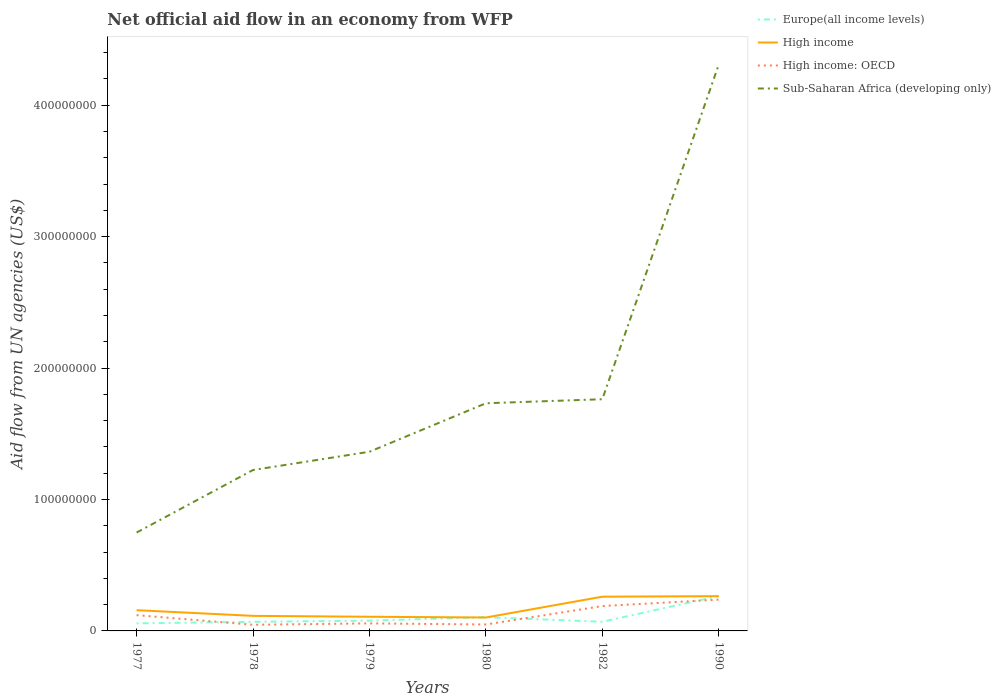Does the line corresponding to Europe(all income levels) intersect with the line corresponding to High income?
Provide a short and direct response. Yes. Across all years, what is the maximum net official aid flow in Europe(all income levels)?
Provide a short and direct response. 5.76e+06. What is the total net official aid flow in High income in the graph?
Offer a very short reply. -1.46e+07. What is the difference between the highest and the second highest net official aid flow in Sub-Saharan Africa (developing only)?
Provide a succinct answer. 3.56e+08. What is the difference between two consecutive major ticks on the Y-axis?
Give a very brief answer. 1.00e+08. Are the values on the major ticks of Y-axis written in scientific E-notation?
Give a very brief answer. No. Does the graph contain grids?
Your response must be concise. No. How many legend labels are there?
Your response must be concise. 4. How are the legend labels stacked?
Make the answer very short. Vertical. What is the title of the graph?
Provide a short and direct response. Net official aid flow in an economy from WFP. What is the label or title of the Y-axis?
Your response must be concise. Aid flow from UN agencies (US$). What is the Aid flow from UN agencies (US$) in Europe(all income levels) in 1977?
Provide a succinct answer. 5.76e+06. What is the Aid flow from UN agencies (US$) of High income in 1977?
Provide a short and direct response. 1.58e+07. What is the Aid flow from UN agencies (US$) of High income: OECD in 1977?
Offer a terse response. 1.20e+07. What is the Aid flow from UN agencies (US$) of Sub-Saharan Africa (developing only) in 1977?
Offer a terse response. 7.48e+07. What is the Aid flow from UN agencies (US$) in Europe(all income levels) in 1978?
Offer a terse response. 6.93e+06. What is the Aid flow from UN agencies (US$) of High income in 1978?
Your answer should be very brief. 1.15e+07. What is the Aid flow from UN agencies (US$) in High income: OECD in 1978?
Your response must be concise. 4.68e+06. What is the Aid flow from UN agencies (US$) in Sub-Saharan Africa (developing only) in 1978?
Keep it short and to the point. 1.22e+08. What is the Aid flow from UN agencies (US$) in Europe(all income levels) in 1979?
Make the answer very short. 7.82e+06. What is the Aid flow from UN agencies (US$) in High income in 1979?
Provide a short and direct response. 1.08e+07. What is the Aid flow from UN agencies (US$) of High income: OECD in 1979?
Give a very brief answer. 5.74e+06. What is the Aid flow from UN agencies (US$) of Sub-Saharan Africa (developing only) in 1979?
Offer a very short reply. 1.36e+08. What is the Aid flow from UN agencies (US$) in Europe(all income levels) in 1980?
Offer a terse response. 1.05e+07. What is the Aid flow from UN agencies (US$) in High income in 1980?
Provide a short and direct response. 1.02e+07. What is the Aid flow from UN agencies (US$) in High income: OECD in 1980?
Offer a very short reply. 4.90e+06. What is the Aid flow from UN agencies (US$) in Sub-Saharan Africa (developing only) in 1980?
Offer a very short reply. 1.73e+08. What is the Aid flow from UN agencies (US$) in Europe(all income levels) in 1982?
Offer a very short reply. 6.96e+06. What is the Aid flow from UN agencies (US$) in High income in 1982?
Provide a short and direct response. 2.60e+07. What is the Aid flow from UN agencies (US$) of High income: OECD in 1982?
Your answer should be compact. 1.89e+07. What is the Aid flow from UN agencies (US$) in Sub-Saharan Africa (developing only) in 1982?
Your answer should be very brief. 1.76e+08. What is the Aid flow from UN agencies (US$) in Europe(all income levels) in 1990?
Offer a terse response. 2.65e+07. What is the Aid flow from UN agencies (US$) of High income in 1990?
Provide a short and direct response. 2.64e+07. What is the Aid flow from UN agencies (US$) in High income: OECD in 1990?
Ensure brevity in your answer.  2.38e+07. What is the Aid flow from UN agencies (US$) in Sub-Saharan Africa (developing only) in 1990?
Offer a very short reply. 4.31e+08. Across all years, what is the maximum Aid flow from UN agencies (US$) in Europe(all income levels)?
Provide a short and direct response. 2.65e+07. Across all years, what is the maximum Aid flow from UN agencies (US$) in High income?
Provide a succinct answer. 2.64e+07. Across all years, what is the maximum Aid flow from UN agencies (US$) in High income: OECD?
Your answer should be compact. 2.38e+07. Across all years, what is the maximum Aid flow from UN agencies (US$) in Sub-Saharan Africa (developing only)?
Ensure brevity in your answer.  4.31e+08. Across all years, what is the minimum Aid flow from UN agencies (US$) in Europe(all income levels)?
Keep it short and to the point. 5.76e+06. Across all years, what is the minimum Aid flow from UN agencies (US$) in High income?
Your response must be concise. 1.02e+07. Across all years, what is the minimum Aid flow from UN agencies (US$) in High income: OECD?
Your response must be concise. 4.68e+06. Across all years, what is the minimum Aid flow from UN agencies (US$) in Sub-Saharan Africa (developing only)?
Offer a very short reply. 7.48e+07. What is the total Aid flow from UN agencies (US$) of Europe(all income levels) in the graph?
Offer a very short reply. 6.45e+07. What is the total Aid flow from UN agencies (US$) of High income in the graph?
Offer a very short reply. 1.01e+08. What is the total Aid flow from UN agencies (US$) in High income: OECD in the graph?
Your answer should be compact. 7.01e+07. What is the total Aid flow from UN agencies (US$) in Sub-Saharan Africa (developing only) in the graph?
Your response must be concise. 1.11e+09. What is the difference between the Aid flow from UN agencies (US$) in Europe(all income levels) in 1977 and that in 1978?
Ensure brevity in your answer.  -1.17e+06. What is the difference between the Aid flow from UN agencies (US$) of High income in 1977 and that in 1978?
Give a very brief answer. 4.32e+06. What is the difference between the Aid flow from UN agencies (US$) of High income: OECD in 1977 and that in 1978?
Make the answer very short. 7.34e+06. What is the difference between the Aid flow from UN agencies (US$) of Sub-Saharan Africa (developing only) in 1977 and that in 1978?
Provide a succinct answer. -4.76e+07. What is the difference between the Aid flow from UN agencies (US$) in Europe(all income levels) in 1977 and that in 1979?
Ensure brevity in your answer.  -2.06e+06. What is the difference between the Aid flow from UN agencies (US$) in High income in 1977 and that in 1979?
Ensure brevity in your answer.  5.01e+06. What is the difference between the Aid flow from UN agencies (US$) of High income: OECD in 1977 and that in 1979?
Give a very brief answer. 6.28e+06. What is the difference between the Aid flow from UN agencies (US$) of Sub-Saharan Africa (developing only) in 1977 and that in 1979?
Ensure brevity in your answer.  -6.15e+07. What is the difference between the Aid flow from UN agencies (US$) in Europe(all income levels) in 1977 and that in 1980?
Make the answer very short. -4.70e+06. What is the difference between the Aid flow from UN agencies (US$) of High income in 1977 and that in 1980?
Keep it short and to the point. 5.57e+06. What is the difference between the Aid flow from UN agencies (US$) of High income: OECD in 1977 and that in 1980?
Your answer should be very brief. 7.12e+06. What is the difference between the Aid flow from UN agencies (US$) in Sub-Saharan Africa (developing only) in 1977 and that in 1980?
Your answer should be very brief. -9.84e+07. What is the difference between the Aid flow from UN agencies (US$) of Europe(all income levels) in 1977 and that in 1982?
Your answer should be very brief. -1.20e+06. What is the difference between the Aid flow from UN agencies (US$) of High income in 1977 and that in 1982?
Provide a succinct answer. -1.03e+07. What is the difference between the Aid flow from UN agencies (US$) in High income: OECD in 1977 and that in 1982?
Give a very brief answer. -6.90e+06. What is the difference between the Aid flow from UN agencies (US$) of Sub-Saharan Africa (developing only) in 1977 and that in 1982?
Give a very brief answer. -1.01e+08. What is the difference between the Aid flow from UN agencies (US$) of Europe(all income levels) in 1977 and that in 1990?
Ensure brevity in your answer.  -2.08e+07. What is the difference between the Aid flow from UN agencies (US$) of High income in 1977 and that in 1990?
Your response must be concise. -1.07e+07. What is the difference between the Aid flow from UN agencies (US$) of High income: OECD in 1977 and that in 1990?
Provide a succinct answer. -1.18e+07. What is the difference between the Aid flow from UN agencies (US$) in Sub-Saharan Africa (developing only) in 1977 and that in 1990?
Provide a succinct answer. -3.56e+08. What is the difference between the Aid flow from UN agencies (US$) of Europe(all income levels) in 1978 and that in 1979?
Your response must be concise. -8.90e+05. What is the difference between the Aid flow from UN agencies (US$) in High income in 1978 and that in 1979?
Offer a terse response. 6.90e+05. What is the difference between the Aid flow from UN agencies (US$) of High income: OECD in 1978 and that in 1979?
Offer a terse response. -1.06e+06. What is the difference between the Aid flow from UN agencies (US$) of Sub-Saharan Africa (developing only) in 1978 and that in 1979?
Make the answer very short. -1.39e+07. What is the difference between the Aid flow from UN agencies (US$) in Europe(all income levels) in 1978 and that in 1980?
Ensure brevity in your answer.  -3.53e+06. What is the difference between the Aid flow from UN agencies (US$) in High income in 1978 and that in 1980?
Provide a succinct answer. 1.25e+06. What is the difference between the Aid flow from UN agencies (US$) of Sub-Saharan Africa (developing only) in 1978 and that in 1980?
Offer a terse response. -5.08e+07. What is the difference between the Aid flow from UN agencies (US$) in High income in 1978 and that in 1982?
Offer a terse response. -1.46e+07. What is the difference between the Aid flow from UN agencies (US$) of High income: OECD in 1978 and that in 1982?
Offer a terse response. -1.42e+07. What is the difference between the Aid flow from UN agencies (US$) in Sub-Saharan Africa (developing only) in 1978 and that in 1982?
Ensure brevity in your answer.  -5.38e+07. What is the difference between the Aid flow from UN agencies (US$) of Europe(all income levels) in 1978 and that in 1990?
Give a very brief answer. -1.96e+07. What is the difference between the Aid flow from UN agencies (US$) of High income in 1978 and that in 1990?
Your answer should be very brief. -1.50e+07. What is the difference between the Aid flow from UN agencies (US$) in High income: OECD in 1978 and that in 1990?
Ensure brevity in your answer.  -1.91e+07. What is the difference between the Aid flow from UN agencies (US$) in Sub-Saharan Africa (developing only) in 1978 and that in 1990?
Your response must be concise. -3.08e+08. What is the difference between the Aid flow from UN agencies (US$) in Europe(all income levels) in 1979 and that in 1980?
Offer a very short reply. -2.64e+06. What is the difference between the Aid flow from UN agencies (US$) in High income in 1979 and that in 1980?
Make the answer very short. 5.60e+05. What is the difference between the Aid flow from UN agencies (US$) of High income: OECD in 1979 and that in 1980?
Your answer should be very brief. 8.40e+05. What is the difference between the Aid flow from UN agencies (US$) of Sub-Saharan Africa (developing only) in 1979 and that in 1980?
Make the answer very short. -3.69e+07. What is the difference between the Aid flow from UN agencies (US$) in Europe(all income levels) in 1979 and that in 1982?
Your answer should be very brief. 8.60e+05. What is the difference between the Aid flow from UN agencies (US$) in High income in 1979 and that in 1982?
Your answer should be compact. -1.53e+07. What is the difference between the Aid flow from UN agencies (US$) in High income: OECD in 1979 and that in 1982?
Ensure brevity in your answer.  -1.32e+07. What is the difference between the Aid flow from UN agencies (US$) of Sub-Saharan Africa (developing only) in 1979 and that in 1982?
Your answer should be compact. -4.00e+07. What is the difference between the Aid flow from UN agencies (US$) of Europe(all income levels) in 1979 and that in 1990?
Your response must be concise. -1.87e+07. What is the difference between the Aid flow from UN agencies (US$) in High income in 1979 and that in 1990?
Keep it short and to the point. -1.57e+07. What is the difference between the Aid flow from UN agencies (US$) in High income: OECD in 1979 and that in 1990?
Provide a succinct answer. -1.81e+07. What is the difference between the Aid flow from UN agencies (US$) of Sub-Saharan Africa (developing only) in 1979 and that in 1990?
Offer a terse response. -2.95e+08. What is the difference between the Aid flow from UN agencies (US$) of Europe(all income levels) in 1980 and that in 1982?
Provide a succinct answer. 3.50e+06. What is the difference between the Aid flow from UN agencies (US$) in High income in 1980 and that in 1982?
Your response must be concise. -1.58e+07. What is the difference between the Aid flow from UN agencies (US$) in High income: OECD in 1980 and that in 1982?
Ensure brevity in your answer.  -1.40e+07. What is the difference between the Aid flow from UN agencies (US$) of Sub-Saharan Africa (developing only) in 1980 and that in 1982?
Your answer should be compact. -3.08e+06. What is the difference between the Aid flow from UN agencies (US$) of Europe(all income levels) in 1980 and that in 1990?
Give a very brief answer. -1.61e+07. What is the difference between the Aid flow from UN agencies (US$) in High income in 1980 and that in 1990?
Make the answer very short. -1.62e+07. What is the difference between the Aid flow from UN agencies (US$) of High income: OECD in 1980 and that in 1990?
Your answer should be very brief. -1.89e+07. What is the difference between the Aid flow from UN agencies (US$) in Sub-Saharan Africa (developing only) in 1980 and that in 1990?
Offer a very short reply. -2.58e+08. What is the difference between the Aid flow from UN agencies (US$) of Europe(all income levels) in 1982 and that in 1990?
Keep it short and to the point. -1.96e+07. What is the difference between the Aid flow from UN agencies (US$) in High income in 1982 and that in 1990?
Offer a very short reply. -3.90e+05. What is the difference between the Aid flow from UN agencies (US$) of High income: OECD in 1982 and that in 1990?
Provide a short and direct response. -4.89e+06. What is the difference between the Aid flow from UN agencies (US$) of Sub-Saharan Africa (developing only) in 1982 and that in 1990?
Keep it short and to the point. -2.55e+08. What is the difference between the Aid flow from UN agencies (US$) in Europe(all income levels) in 1977 and the Aid flow from UN agencies (US$) in High income in 1978?
Offer a terse response. -5.70e+06. What is the difference between the Aid flow from UN agencies (US$) of Europe(all income levels) in 1977 and the Aid flow from UN agencies (US$) of High income: OECD in 1978?
Your response must be concise. 1.08e+06. What is the difference between the Aid flow from UN agencies (US$) of Europe(all income levels) in 1977 and the Aid flow from UN agencies (US$) of Sub-Saharan Africa (developing only) in 1978?
Your answer should be compact. -1.17e+08. What is the difference between the Aid flow from UN agencies (US$) of High income in 1977 and the Aid flow from UN agencies (US$) of High income: OECD in 1978?
Keep it short and to the point. 1.11e+07. What is the difference between the Aid flow from UN agencies (US$) of High income in 1977 and the Aid flow from UN agencies (US$) of Sub-Saharan Africa (developing only) in 1978?
Provide a succinct answer. -1.07e+08. What is the difference between the Aid flow from UN agencies (US$) in High income: OECD in 1977 and the Aid flow from UN agencies (US$) in Sub-Saharan Africa (developing only) in 1978?
Your answer should be very brief. -1.10e+08. What is the difference between the Aid flow from UN agencies (US$) of Europe(all income levels) in 1977 and the Aid flow from UN agencies (US$) of High income in 1979?
Provide a short and direct response. -5.01e+06. What is the difference between the Aid flow from UN agencies (US$) in Europe(all income levels) in 1977 and the Aid flow from UN agencies (US$) in High income: OECD in 1979?
Offer a very short reply. 2.00e+04. What is the difference between the Aid flow from UN agencies (US$) of Europe(all income levels) in 1977 and the Aid flow from UN agencies (US$) of Sub-Saharan Africa (developing only) in 1979?
Your answer should be very brief. -1.31e+08. What is the difference between the Aid flow from UN agencies (US$) of High income in 1977 and the Aid flow from UN agencies (US$) of High income: OECD in 1979?
Make the answer very short. 1.00e+07. What is the difference between the Aid flow from UN agencies (US$) in High income in 1977 and the Aid flow from UN agencies (US$) in Sub-Saharan Africa (developing only) in 1979?
Your answer should be compact. -1.21e+08. What is the difference between the Aid flow from UN agencies (US$) in High income: OECD in 1977 and the Aid flow from UN agencies (US$) in Sub-Saharan Africa (developing only) in 1979?
Ensure brevity in your answer.  -1.24e+08. What is the difference between the Aid flow from UN agencies (US$) in Europe(all income levels) in 1977 and the Aid flow from UN agencies (US$) in High income in 1980?
Keep it short and to the point. -4.45e+06. What is the difference between the Aid flow from UN agencies (US$) of Europe(all income levels) in 1977 and the Aid flow from UN agencies (US$) of High income: OECD in 1980?
Your answer should be compact. 8.60e+05. What is the difference between the Aid flow from UN agencies (US$) of Europe(all income levels) in 1977 and the Aid flow from UN agencies (US$) of Sub-Saharan Africa (developing only) in 1980?
Offer a very short reply. -1.67e+08. What is the difference between the Aid flow from UN agencies (US$) of High income in 1977 and the Aid flow from UN agencies (US$) of High income: OECD in 1980?
Offer a very short reply. 1.09e+07. What is the difference between the Aid flow from UN agencies (US$) in High income in 1977 and the Aid flow from UN agencies (US$) in Sub-Saharan Africa (developing only) in 1980?
Provide a succinct answer. -1.57e+08. What is the difference between the Aid flow from UN agencies (US$) of High income: OECD in 1977 and the Aid flow from UN agencies (US$) of Sub-Saharan Africa (developing only) in 1980?
Ensure brevity in your answer.  -1.61e+08. What is the difference between the Aid flow from UN agencies (US$) in Europe(all income levels) in 1977 and the Aid flow from UN agencies (US$) in High income in 1982?
Provide a short and direct response. -2.03e+07. What is the difference between the Aid flow from UN agencies (US$) of Europe(all income levels) in 1977 and the Aid flow from UN agencies (US$) of High income: OECD in 1982?
Your answer should be compact. -1.32e+07. What is the difference between the Aid flow from UN agencies (US$) in Europe(all income levels) in 1977 and the Aid flow from UN agencies (US$) in Sub-Saharan Africa (developing only) in 1982?
Ensure brevity in your answer.  -1.71e+08. What is the difference between the Aid flow from UN agencies (US$) in High income in 1977 and the Aid flow from UN agencies (US$) in High income: OECD in 1982?
Provide a short and direct response. -3.14e+06. What is the difference between the Aid flow from UN agencies (US$) in High income in 1977 and the Aid flow from UN agencies (US$) in Sub-Saharan Africa (developing only) in 1982?
Your response must be concise. -1.61e+08. What is the difference between the Aid flow from UN agencies (US$) of High income: OECD in 1977 and the Aid flow from UN agencies (US$) of Sub-Saharan Africa (developing only) in 1982?
Offer a terse response. -1.64e+08. What is the difference between the Aid flow from UN agencies (US$) of Europe(all income levels) in 1977 and the Aid flow from UN agencies (US$) of High income in 1990?
Offer a terse response. -2.07e+07. What is the difference between the Aid flow from UN agencies (US$) of Europe(all income levels) in 1977 and the Aid flow from UN agencies (US$) of High income: OECD in 1990?
Make the answer very short. -1.80e+07. What is the difference between the Aid flow from UN agencies (US$) in Europe(all income levels) in 1977 and the Aid flow from UN agencies (US$) in Sub-Saharan Africa (developing only) in 1990?
Offer a terse response. -4.25e+08. What is the difference between the Aid flow from UN agencies (US$) in High income in 1977 and the Aid flow from UN agencies (US$) in High income: OECD in 1990?
Offer a very short reply. -8.03e+06. What is the difference between the Aid flow from UN agencies (US$) of High income in 1977 and the Aid flow from UN agencies (US$) of Sub-Saharan Africa (developing only) in 1990?
Offer a terse response. -4.15e+08. What is the difference between the Aid flow from UN agencies (US$) of High income: OECD in 1977 and the Aid flow from UN agencies (US$) of Sub-Saharan Africa (developing only) in 1990?
Your answer should be compact. -4.19e+08. What is the difference between the Aid flow from UN agencies (US$) in Europe(all income levels) in 1978 and the Aid flow from UN agencies (US$) in High income in 1979?
Offer a very short reply. -3.84e+06. What is the difference between the Aid flow from UN agencies (US$) of Europe(all income levels) in 1978 and the Aid flow from UN agencies (US$) of High income: OECD in 1979?
Keep it short and to the point. 1.19e+06. What is the difference between the Aid flow from UN agencies (US$) in Europe(all income levels) in 1978 and the Aid flow from UN agencies (US$) in Sub-Saharan Africa (developing only) in 1979?
Your response must be concise. -1.29e+08. What is the difference between the Aid flow from UN agencies (US$) of High income in 1978 and the Aid flow from UN agencies (US$) of High income: OECD in 1979?
Your answer should be compact. 5.72e+06. What is the difference between the Aid flow from UN agencies (US$) of High income in 1978 and the Aid flow from UN agencies (US$) of Sub-Saharan Africa (developing only) in 1979?
Provide a succinct answer. -1.25e+08. What is the difference between the Aid flow from UN agencies (US$) of High income: OECD in 1978 and the Aid flow from UN agencies (US$) of Sub-Saharan Africa (developing only) in 1979?
Your answer should be compact. -1.32e+08. What is the difference between the Aid flow from UN agencies (US$) of Europe(all income levels) in 1978 and the Aid flow from UN agencies (US$) of High income in 1980?
Your answer should be compact. -3.28e+06. What is the difference between the Aid flow from UN agencies (US$) of Europe(all income levels) in 1978 and the Aid flow from UN agencies (US$) of High income: OECD in 1980?
Provide a short and direct response. 2.03e+06. What is the difference between the Aid flow from UN agencies (US$) of Europe(all income levels) in 1978 and the Aid flow from UN agencies (US$) of Sub-Saharan Africa (developing only) in 1980?
Your response must be concise. -1.66e+08. What is the difference between the Aid flow from UN agencies (US$) of High income in 1978 and the Aid flow from UN agencies (US$) of High income: OECD in 1980?
Offer a terse response. 6.56e+06. What is the difference between the Aid flow from UN agencies (US$) in High income in 1978 and the Aid flow from UN agencies (US$) in Sub-Saharan Africa (developing only) in 1980?
Keep it short and to the point. -1.62e+08. What is the difference between the Aid flow from UN agencies (US$) in High income: OECD in 1978 and the Aid flow from UN agencies (US$) in Sub-Saharan Africa (developing only) in 1980?
Your answer should be compact. -1.69e+08. What is the difference between the Aid flow from UN agencies (US$) in Europe(all income levels) in 1978 and the Aid flow from UN agencies (US$) in High income in 1982?
Offer a very short reply. -1.91e+07. What is the difference between the Aid flow from UN agencies (US$) of Europe(all income levels) in 1978 and the Aid flow from UN agencies (US$) of High income: OECD in 1982?
Keep it short and to the point. -1.20e+07. What is the difference between the Aid flow from UN agencies (US$) in Europe(all income levels) in 1978 and the Aid flow from UN agencies (US$) in Sub-Saharan Africa (developing only) in 1982?
Make the answer very short. -1.69e+08. What is the difference between the Aid flow from UN agencies (US$) of High income in 1978 and the Aid flow from UN agencies (US$) of High income: OECD in 1982?
Offer a terse response. -7.46e+06. What is the difference between the Aid flow from UN agencies (US$) in High income in 1978 and the Aid flow from UN agencies (US$) in Sub-Saharan Africa (developing only) in 1982?
Your answer should be very brief. -1.65e+08. What is the difference between the Aid flow from UN agencies (US$) of High income: OECD in 1978 and the Aid flow from UN agencies (US$) of Sub-Saharan Africa (developing only) in 1982?
Provide a short and direct response. -1.72e+08. What is the difference between the Aid flow from UN agencies (US$) in Europe(all income levels) in 1978 and the Aid flow from UN agencies (US$) in High income in 1990?
Offer a very short reply. -1.95e+07. What is the difference between the Aid flow from UN agencies (US$) in Europe(all income levels) in 1978 and the Aid flow from UN agencies (US$) in High income: OECD in 1990?
Your answer should be compact. -1.69e+07. What is the difference between the Aid flow from UN agencies (US$) of Europe(all income levels) in 1978 and the Aid flow from UN agencies (US$) of Sub-Saharan Africa (developing only) in 1990?
Your answer should be very brief. -4.24e+08. What is the difference between the Aid flow from UN agencies (US$) in High income in 1978 and the Aid flow from UN agencies (US$) in High income: OECD in 1990?
Your response must be concise. -1.24e+07. What is the difference between the Aid flow from UN agencies (US$) in High income in 1978 and the Aid flow from UN agencies (US$) in Sub-Saharan Africa (developing only) in 1990?
Offer a terse response. -4.19e+08. What is the difference between the Aid flow from UN agencies (US$) of High income: OECD in 1978 and the Aid flow from UN agencies (US$) of Sub-Saharan Africa (developing only) in 1990?
Provide a short and direct response. -4.26e+08. What is the difference between the Aid flow from UN agencies (US$) in Europe(all income levels) in 1979 and the Aid flow from UN agencies (US$) in High income in 1980?
Provide a short and direct response. -2.39e+06. What is the difference between the Aid flow from UN agencies (US$) of Europe(all income levels) in 1979 and the Aid flow from UN agencies (US$) of High income: OECD in 1980?
Make the answer very short. 2.92e+06. What is the difference between the Aid flow from UN agencies (US$) of Europe(all income levels) in 1979 and the Aid flow from UN agencies (US$) of Sub-Saharan Africa (developing only) in 1980?
Give a very brief answer. -1.65e+08. What is the difference between the Aid flow from UN agencies (US$) in High income in 1979 and the Aid flow from UN agencies (US$) in High income: OECD in 1980?
Offer a terse response. 5.87e+06. What is the difference between the Aid flow from UN agencies (US$) of High income in 1979 and the Aid flow from UN agencies (US$) of Sub-Saharan Africa (developing only) in 1980?
Your answer should be very brief. -1.62e+08. What is the difference between the Aid flow from UN agencies (US$) of High income: OECD in 1979 and the Aid flow from UN agencies (US$) of Sub-Saharan Africa (developing only) in 1980?
Ensure brevity in your answer.  -1.67e+08. What is the difference between the Aid flow from UN agencies (US$) of Europe(all income levels) in 1979 and the Aid flow from UN agencies (US$) of High income in 1982?
Ensure brevity in your answer.  -1.82e+07. What is the difference between the Aid flow from UN agencies (US$) of Europe(all income levels) in 1979 and the Aid flow from UN agencies (US$) of High income: OECD in 1982?
Provide a succinct answer. -1.11e+07. What is the difference between the Aid flow from UN agencies (US$) in Europe(all income levels) in 1979 and the Aid flow from UN agencies (US$) in Sub-Saharan Africa (developing only) in 1982?
Keep it short and to the point. -1.68e+08. What is the difference between the Aid flow from UN agencies (US$) of High income in 1979 and the Aid flow from UN agencies (US$) of High income: OECD in 1982?
Your answer should be compact. -8.15e+06. What is the difference between the Aid flow from UN agencies (US$) of High income in 1979 and the Aid flow from UN agencies (US$) of Sub-Saharan Africa (developing only) in 1982?
Ensure brevity in your answer.  -1.66e+08. What is the difference between the Aid flow from UN agencies (US$) of High income: OECD in 1979 and the Aid flow from UN agencies (US$) of Sub-Saharan Africa (developing only) in 1982?
Ensure brevity in your answer.  -1.71e+08. What is the difference between the Aid flow from UN agencies (US$) of Europe(all income levels) in 1979 and the Aid flow from UN agencies (US$) of High income in 1990?
Your answer should be very brief. -1.86e+07. What is the difference between the Aid flow from UN agencies (US$) of Europe(all income levels) in 1979 and the Aid flow from UN agencies (US$) of High income: OECD in 1990?
Your response must be concise. -1.60e+07. What is the difference between the Aid flow from UN agencies (US$) of Europe(all income levels) in 1979 and the Aid flow from UN agencies (US$) of Sub-Saharan Africa (developing only) in 1990?
Make the answer very short. -4.23e+08. What is the difference between the Aid flow from UN agencies (US$) in High income in 1979 and the Aid flow from UN agencies (US$) in High income: OECD in 1990?
Give a very brief answer. -1.30e+07. What is the difference between the Aid flow from UN agencies (US$) of High income in 1979 and the Aid flow from UN agencies (US$) of Sub-Saharan Africa (developing only) in 1990?
Keep it short and to the point. -4.20e+08. What is the difference between the Aid flow from UN agencies (US$) of High income: OECD in 1979 and the Aid flow from UN agencies (US$) of Sub-Saharan Africa (developing only) in 1990?
Keep it short and to the point. -4.25e+08. What is the difference between the Aid flow from UN agencies (US$) in Europe(all income levels) in 1980 and the Aid flow from UN agencies (US$) in High income in 1982?
Make the answer very short. -1.56e+07. What is the difference between the Aid flow from UN agencies (US$) in Europe(all income levels) in 1980 and the Aid flow from UN agencies (US$) in High income: OECD in 1982?
Provide a short and direct response. -8.46e+06. What is the difference between the Aid flow from UN agencies (US$) in Europe(all income levels) in 1980 and the Aid flow from UN agencies (US$) in Sub-Saharan Africa (developing only) in 1982?
Give a very brief answer. -1.66e+08. What is the difference between the Aid flow from UN agencies (US$) in High income in 1980 and the Aid flow from UN agencies (US$) in High income: OECD in 1982?
Keep it short and to the point. -8.71e+06. What is the difference between the Aid flow from UN agencies (US$) in High income in 1980 and the Aid flow from UN agencies (US$) in Sub-Saharan Africa (developing only) in 1982?
Make the answer very short. -1.66e+08. What is the difference between the Aid flow from UN agencies (US$) of High income: OECD in 1980 and the Aid flow from UN agencies (US$) of Sub-Saharan Africa (developing only) in 1982?
Provide a short and direct response. -1.71e+08. What is the difference between the Aid flow from UN agencies (US$) of Europe(all income levels) in 1980 and the Aid flow from UN agencies (US$) of High income in 1990?
Your response must be concise. -1.60e+07. What is the difference between the Aid flow from UN agencies (US$) of Europe(all income levels) in 1980 and the Aid flow from UN agencies (US$) of High income: OECD in 1990?
Offer a very short reply. -1.34e+07. What is the difference between the Aid flow from UN agencies (US$) of Europe(all income levels) in 1980 and the Aid flow from UN agencies (US$) of Sub-Saharan Africa (developing only) in 1990?
Your response must be concise. -4.20e+08. What is the difference between the Aid flow from UN agencies (US$) in High income in 1980 and the Aid flow from UN agencies (US$) in High income: OECD in 1990?
Give a very brief answer. -1.36e+07. What is the difference between the Aid flow from UN agencies (US$) in High income in 1980 and the Aid flow from UN agencies (US$) in Sub-Saharan Africa (developing only) in 1990?
Ensure brevity in your answer.  -4.21e+08. What is the difference between the Aid flow from UN agencies (US$) in High income: OECD in 1980 and the Aid flow from UN agencies (US$) in Sub-Saharan Africa (developing only) in 1990?
Give a very brief answer. -4.26e+08. What is the difference between the Aid flow from UN agencies (US$) in Europe(all income levels) in 1982 and the Aid flow from UN agencies (US$) in High income in 1990?
Provide a short and direct response. -1.95e+07. What is the difference between the Aid flow from UN agencies (US$) of Europe(all income levels) in 1982 and the Aid flow from UN agencies (US$) of High income: OECD in 1990?
Make the answer very short. -1.68e+07. What is the difference between the Aid flow from UN agencies (US$) in Europe(all income levels) in 1982 and the Aid flow from UN agencies (US$) in Sub-Saharan Africa (developing only) in 1990?
Your answer should be compact. -4.24e+08. What is the difference between the Aid flow from UN agencies (US$) in High income in 1982 and the Aid flow from UN agencies (US$) in High income: OECD in 1990?
Offer a terse response. 2.24e+06. What is the difference between the Aid flow from UN agencies (US$) of High income in 1982 and the Aid flow from UN agencies (US$) of Sub-Saharan Africa (developing only) in 1990?
Your response must be concise. -4.05e+08. What is the difference between the Aid flow from UN agencies (US$) in High income: OECD in 1982 and the Aid flow from UN agencies (US$) in Sub-Saharan Africa (developing only) in 1990?
Give a very brief answer. -4.12e+08. What is the average Aid flow from UN agencies (US$) of Europe(all income levels) per year?
Offer a very short reply. 1.07e+07. What is the average Aid flow from UN agencies (US$) in High income per year?
Offer a very short reply. 1.68e+07. What is the average Aid flow from UN agencies (US$) of High income: OECD per year?
Your response must be concise. 1.17e+07. What is the average Aid flow from UN agencies (US$) of Sub-Saharan Africa (developing only) per year?
Keep it short and to the point. 1.86e+08. In the year 1977, what is the difference between the Aid flow from UN agencies (US$) of Europe(all income levels) and Aid flow from UN agencies (US$) of High income?
Ensure brevity in your answer.  -1.00e+07. In the year 1977, what is the difference between the Aid flow from UN agencies (US$) of Europe(all income levels) and Aid flow from UN agencies (US$) of High income: OECD?
Your answer should be compact. -6.26e+06. In the year 1977, what is the difference between the Aid flow from UN agencies (US$) of Europe(all income levels) and Aid flow from UN agencies (US$) of Sub-Saharan Africa (developing only)?
Your answer should be compact. -6.91e+07. In the year 1977, what is the difference between the Aid flow from UN agencies (US$) in High income and Aid flow from UN agencies (US$) in High income: OECD?
Offer a terse response. 3.76e+06. In the year 1977, what is the difference between the Aid flow from UN agencies (US$) in High income and Aid flow from UN agencies (US$) in Sub-Saharan Africa (developing only)?
Ensure brevity in your answer.  -5.91e+07. In the year 1977, what is the difference between the Aid flow from UN agencies (US$) in High income: OECD and Aid flow from UN agencies (US$) in Sub-Saharan Africa (developing only)?
Ensure brevity in your answer.  -6.28e+07. In the year 1978, what is the difference between the Aid flow from UN agencies (US$) in Europe(all income levels) and Aid flow from UN agencies (US$) in High income?
Your response must be concise. -4.53e+06. In the year 1978, what is the difference between the Aid flow from UN agencies (US$) in Europe(all income levels) and Aid flow from UN agencies (US$) in High income: OECD?
Offer a very short reply. 2.25e+06. In the year 1978, what is the difference between the Aid flow from UN agencies (US$) of Europe(all income levels) and Aid flow from UN agencies (US$) of Sub-Saharan Africa (developing only)?
Provide a succinct answer. -1.16e+08. In the year 1978, what is the difference between the Aid flow from UN agencies (US$) of High income and Aid flow from UN agencies (US$) of High income: OECD?
Offer a terse response. 6.78e+06. In the year 1978, what is the difference between the Aid flow from UN agencies (US$) in High income and Aid flow from UN agencies (US$) in Sub-Saharan Africa (developing only)?
Offer a very short reply. -1.11e+08. In the year 1978, what is the difference between the Aid flow from UN agencies (US$) of High income: OECD and Aid flow from UN agencies (US$) of Sub-Saharan Africa (developing only)?
Offer a terse response. -1.18e+08. In the year 1979, what is the difference between the Aid flow from UN agencies (US$) in Europe(all income levels) and Aid flow from UN agencies (US$) in High income?
Your answer should be very brief. -2.95e+06. In the year 1979, what is the difference between the Aid flow from UN agencies (US$) in Europe(all income levels) and Aid flow from UN agencies (US$) in High income: OECD?
Offer a terse response. 2.08e+06. In the year 1979, what is the difference between the Aid flow from UN agencies (US$) of Europe(all income levels) and Aid flow from UN agencies (US$) of Sub-Saharan Africa (developing only)?
Provide a short and direct response. -1.28e+08. In the year 1979, what is the difference between the Aid flow from UN agencies (US$) of High income and Aid flow from UN agencies (US$) of High income: OECD?
Your answer should be compact. 5.03e+06. In the year 1979, what is the difference between the Aid flow from UN agencies (US$) in High income and Aid flow from UN agencies (US$) in Sub-Saharan Africa (developing only)?
Give a very brief answer. -1.26e+08. In the year 1979, what is the difference between the Aid flow from UN agencies (US$) in High income: OECD and Aid flow from UN agencies (US$) in Sub-Saharan Africa (developing only)?
Offer a very short reply. -1.31e+08. In the year 1980, what is the difference between the Aid flow from UN agencies (US$) of Europe(all income levels) and Aid flow from UN agencies (US$) of High income: OECD?
Offer a very short reply. 5.56e+06. In the year 1980, what is the difference between the Aid flow from UN agencies (US$) in Europe(all income levels) and Aid flow from UN agencies (US$) in Sub-Saharan Africa (developing only)?
Offer a very short reply. -1.63e+08. In the year 1980, what is the difference between the Aid flow from UN agencies (US$) in High income and Aid flow from UN agencies (US$) in High income: OECD?
Keep it short and to the point. 5.31e+06. In the year 1980, what is the difference between the Aid flow from UN agencies (US$) in High income and Aid flow from UN agencies (US$) in Sub-Saharan Africa (developing only)?
Make the answer very short. -1.63e+08. In the year 1980, what is the difference between the Aid flow from UN agencies (US$) of High income: OECD and Aid flow from UN agencies (US$) of Sub-Saharan Africa (developing only)?
Make the answer very short. -1.68e+08. In the year 1982, what is the difference between the Aid flow from UN agencies (US$) of Europe(all income levels) and Aid flow from UN agencies (US$) of High income?
Your response must be concise. -1.91e+07. In the year 1982, what is the difference between the Aid flow from UN agencies (US$) in Europe(all income levels) and Aid flow from UN agencies (US$) in High income: OECD?
Offer a terse response. -1.20e+07. In the year 1982, what is the difference between the Aid flow from UN agencies (US$) in Europe(all income levels) and Aid flow from UN agencies (US$) in Sub-Saharan Africa (developing only)?
Keep it short and to the point. -1.69e+08. In the year 1982, what is the difference between the Aid flow from UN agencies (US$) of High income and Aid flow from UN agencies (US$) of High income: OECD?
Provide a succinct answer. 7.13e+06. In the year 1982, what is the difference between the Aid flow from UN agencies (US$) of High income and Aid flow from UN agencies (US$) of Sub-Saharan Africa (developing only)?
Your answer should be compact. -1.50e+08. In the year 1982, what is the difference between the Aid flow from UN agencies (US$) in High income: OECD and Aid flow from UN agencies (US$) in Sub-Saharan Africa (developing only)?
Provide a succinct answer. -1.57e+08. In the year 1990, what is the difference between the Aid flow from UN agencies (US$) of Europe(all income levels) and Aid flow from UN agencies (US$) of High income?
Offer a very short reply. 1.00e+05. In the year 1990, what is the difference between the Aid flow from UN agencies (US$) of Europe(all income levels) and Aid flow from UN agencies (US$) of High income: OECD?
Ensure brevity in your answer.  2.73e+06. In the year 1990, what is the difference between the Aid flow from UN agencies (US$) of Europe(all income levels) and Aid flow from UN agencies (US$) of Sub-Saharan Africa (developing only)?
Offer a very short reply. -4.04e+08. In the year 1990, what is the difference between the Aid flow from UN agencies (US$) of High income and Aid flow from UN agencies (US$) of High income: OECD?
Your answer should be compact. 2.63e+06. In the year 1990, what is the difference between the Aid flow from UN agencies (US$) of High income and Aid flow from UN agencies (US$) of Sub-Saharan Africa (developing only)?
Your answer should be very brief. -4.04e+08. In the year 1990, what is the difference between the Aid flow from UN agencies (US$) in High income: OECD and Aid flow from UN agencies (US$) in Sub-Saharan Africa (developing only)?
Your answer should be compact. -4.07e+08. What is the ratio of the Aid flow from UN agencies (US$) of Europe(all income levels) in 1977 to that in 1978?
Ensure brevity in your answer.  0.83. What is the ratio of the Aid flow from UN agencies (US$) in High income in 1977 to that in 1978?
Keep it short and to the point. 1.38. What is the ratio of the Aid flow from UN agencies (US$) of High income: OECD in 1977 to that in 1978?
Your response must be concise. 2.57. What is the ratio of the Aid flow from UN agencies (US$) of Sub-Saharan Africa (developing only) in 1977 to that in 1978?
Keep it short and to the point. 0.61. What is the ratio of the Aid flow from UN agencies (US$) of Europe(all income levels) in 1977 to that in 1979?
Give a very brief answer. 0.74. What is the ratio of the Aid flow from UN agencies (US$) in High income in 1977 to that in 1979?
Ensure brevity in your answer.  1.47. What is the ratio of the Aid flow from UN agencies (US$) of High income: OECD in 1977 to that in 1979?
Offer a very short reply. 2.09. What is the ratio of the Aid flow from UN agencies (US$) in Sub-Saharan Africa (developing only) in 1977 to that in 1979?
Ensure brevity in your answer.  0.55. What is the ratio of the Aid flow from UN agencies (US$) of Europe(all income levels) in 1977 to that in 1980?
Provide a short and direct response. 0.55. What is the ratio of the Aid flow from UN agencies (US$) in High income in 1977 to that in 1980?
Keep it short and to the point. 1.55. What is the ratio of the Aid flow from UN agencies (US$) in High income: OECD in 1977 to that in 1980?
Offer a terse response. 2.45. What is the ratio of the Aid flow from UN agencies (US$) in Sub-Saharan Africa (developing only) in 1977 to that in 1980?
Your answer should be compact. 0.43. What is the ratio of the Aid flow from UN agencies (US$) of Europe(all income levels) in 1977 to that in 1982?
Keep it short and to the point. 0.83. What is the ratio of the Aid flow from UN agencies (US$) of High income in 1977 to that in 1982?
Offer a terse response. 0.61. What is the ratio of the Aid flow from UN agencies (US$) of High income: OECD in 1977 to that in 1982?
Your response must be concise. 0.64. What is the ratio of the Aid flow from UN agencies (US$) in Sub-Saharan Africa (developing only) in 1977 to that in 1982?
Make the answer very short. 0.42. What is the ratio of the Aid flow from UN agencies (US$) of Europe(all income levels) in 1977 to that in 1990?
Your response must be concise. 0.22. What is the ratio of the Aid flow from UN agencies (US$) in High income in 1977 to that in 1990?
Keep it short and to the point. 0.6. What is the ratio of the Aid flow from UN agencies (US$) in High income: OECD in 1977 to that in 1990?
Keep it short and to the point. 0.5. What is the ratio of the Aid flow from UN agencies (US$) of Sub-Saharan Africa (developing only) in 1977 to that in 1990?
Keep it short and to the point. 0.17. What is the ratio of the Aid flow from UN agencies (US$) of Europe(all income levels) in 1978 to that in 1979?
Keep it short and to the point. 0.89. What is the ratio of the Aid flow from UN agencies (US$) of High income in 1978 to that in 1979?
Your response must be concise. 1.06. What is the ratio of the Aid flow from UN agencies (US$) in High income: OECD in 1978 to that in 1979?
Give a very brief answer. 0.82. What is the ratio of the Aid flow from UN agencies (US$) of Sub-Saharan Africa (developing only) in 1978 to that in 1979?
Your response must be concise. 0.9. What is the ratio of the Aid flow from UN agencies (US$) in Europe(all income levels) in 1978 to that in 1980?
Your response must be concise. 0.66. What is the ratio of the Aid flow from UN agencies (US$) in High income in 1978 to that in 1980?
Give a very brief answer. 1.12. What is the ratio of the Aid flow from UN agencies (US$) of High income: OECD in 1978 to that in 1980?
Offer a very short reply. 0.96. What is the ratio of the Aid flow from UN agencies (US$) of Sub-Saharan Africa (developing only) in 1978 to that in 1980?
Ensure brevity in your answer.  0.71. What is the ratio of the Aid flow from UN agencies (US$) of High income in 1978 to that in 1982?
Provide a short and direct response. 0.44. What is the ratio of the Aid flow from UN agencies (US$) in High income: OECD in 1978 to that in 1982?
Offer a terse response. 0.25. What is the ratio of the Aid flow from UN agencies (US$) in Sub-Saharan Africa (developing only) in 1978 to that in 1982?
Provide a short and direct response. 0.69. What is the ratio of the Aid flow from UN agencies (US$) of Europe(all income levels) in 1978 to that in 1990?
Ensure brevity in your answer.  0.26. What is the ratio of the Aid flow from UN agencies (US$) in High income in 1978 to that in 1990?
Offer a terse response. 0.43. What is the ratio of the Aid flow from UN agencies (US$) in High income: OECD in 1978 to that in 1990?
Offer a very short reply. 0.2. What is the ratio of the Aid flow from UN agencies (US$) of Sub-Saharan Africa (developing only) in 1978 to that in 1990?
Offer a terse response. 0.28. What is the ratio of the Aid flow from UN agencies (US$) of Europe(all income levels) in 1979 to that in 1980?
Your answer should be compact. 0.75. What is the ratio of the Aid flow from UN agencies (US$) of High income in 1979 to that in 1980?
Keep it short and to the point. 1.05. What is the ratio of the Aid flow from UN agencies (US$) of High income: OECD in 1979 to that in 1980?
Your response must be concise. 1.17. What is the ratio of the Aid flow from UN agencies (US$) in Sub-Saharan Africa (developing only) in 1979 to that in 1980?
Your answer should be compact. 0.79. What is the ratio of the Aid flow from UN agencies (US$) in Europe(all income levels) in 1979 to that in 1982?
Ensure brevity in your answer.  1.12. What is the ratio of the Aid flow from UN agencies (US$) in High income in 1979 to that in 1982?
Your answer should be very brief. 0.41. What is the ratio of the Aid flow from UN agencies (US$) in High income: OECD in 1979 to that in 1982?
Give a very brief answer. 0.3. What is the ratio of the Aid flow from UN agencies (US$) in Sub-Saharan Africa (developing only) in 1979 to that in 1982?
Offer a very short reply. 0.77. What is the ratio of the Aid flow from UN agencies (US$) of Europe(all income levels) in 1979 to that in 1990?
Provide a succinct answer. 0.29. What is the ratio of the Aid flow from UN agencies (US$) in High income in 1979 to that in 1990?
Keep it short and to the point. 0.41. What is the ratio of the Aid flow from UN agencies (US$) in High income: OECD in 1979 to that in 1990?
Give a very brief answer. 0.24. What is the ratio of the Aid flow from UN agencies (US$) of Sub-Saharan Africa (developing only) in 1979 to that in 1990?
Offer a very short reply. 0.32. What is the ratio of the Aid flow from UN agencies (US$) in Europe(all income levels) in 1980 to that in 1982?
Provide a succinct answer. 1.5. What is the ratio of the Aid flow from UN agencies (US$) in High income in 1980 to that in 1982?
Make the answer very short. 0.39. What is the ratio of the Aid flow from UN agencies (US$) in High income: OECD in 1980 to that in 1982?
Provide a short and direct response. 0.26. What is the ratio of the Aid flow from UN agencies (US$) of Sub-Saharan Africa (developing only) in 1980 to that in 1982?
Make the answer very short. 0.98. What is the ratio of the Aid flow from UN agencies (US$) in Europe(all income levels) in 1980 to that in 1990?
Provide a succinct answer. 0.39. What is the ratio of the Aid flow from UN agencies (US$) of High income in 1980 to that in 1990?
Keep it short and to the point. 0.39. What is the ratio of the Aid flow from UN agencies (US$) of High income: OECD in 1980 to that in 1990?
Your answer should be compact. 0.21. What is the ratio of the Aid flow from UN agencies (US$) in Sub-Saharan Africa (developing only) in 1980 to that in 1990?
Your answer should be compact. 0.4. What is the ratio of the Aid flow from UN agencies (US$) of Europe(all income levels) in 1982 to that in 1990?
Make the answer very short. 0.26. What is the ratio of the Aid flow from UN agencies (US$) of High income in 1982 to that in 1990?
Your answer should be compact. 0.99. What is the ratio of the Aid flow from UN agencies (US$) of High income: OECD in 1982 to that in 1990?
Ensure brevity in your answer.  0.79. What is the ratio of the Aid flow from UN agencies (US$) in Sub-Saharan Africa (developing only) in 1982 to that in 1990?
Your response must be concise. 0.41. What is the difference between the highest and the second highest Aid flow from UN agencies (US$) in Europe(all income levels)?
Provide a short and direct response. 1.61e+07. What is the difference between the highest and the second highest Aid flow from UN agencies (US$) in High income?
Your answer should be very brief. 3.90e+05. What is the difference between the highest and the second highest Aid flow from UN agencies (US$) of High income: OECD?
Ensure brevity in your answer.  4.89e+06. What is the difference between the highest and the second highest Aid flow from UN agencies (US$) of Sub-Saharan Africa (developing only)?
Your answer should be very brief. 2.55e+08. What is the difference between the highest and the lowest Aid flow from UN agencies (US$) of Europe(all income levels)?
Keep it short and to the point. 2.08e+07. What is the difference between the highest and the lowest Aid flow from UN agencies (US$) of High income?
Make the answer very short. 1.62e+07. What is the difference between the highest and the lowest Aid flow from UN agencies (US$) of High income: OECD?
Ensure brevity in your answer.  1.91e+07. What is the difference between the highest and the lowest Aid flow from UN agencies (US$) of Sub-Saharan Africa (developing only)?
Offer a terse response. 3.56e+08. 